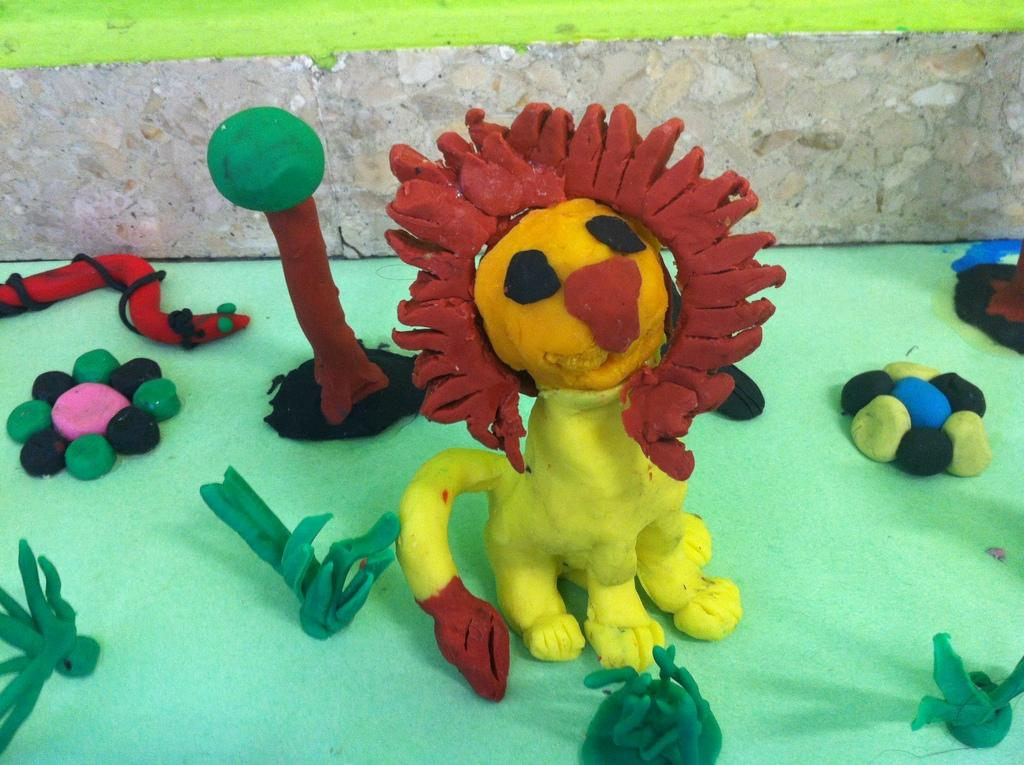What is located at the bottom of the image? There is a table at the bottom of the image. What type of objects are on the table? Toys made of clay are present on the table. What time is depicted in the image? The image does not depict a specific time; it only shows a table with clay toys on it. 